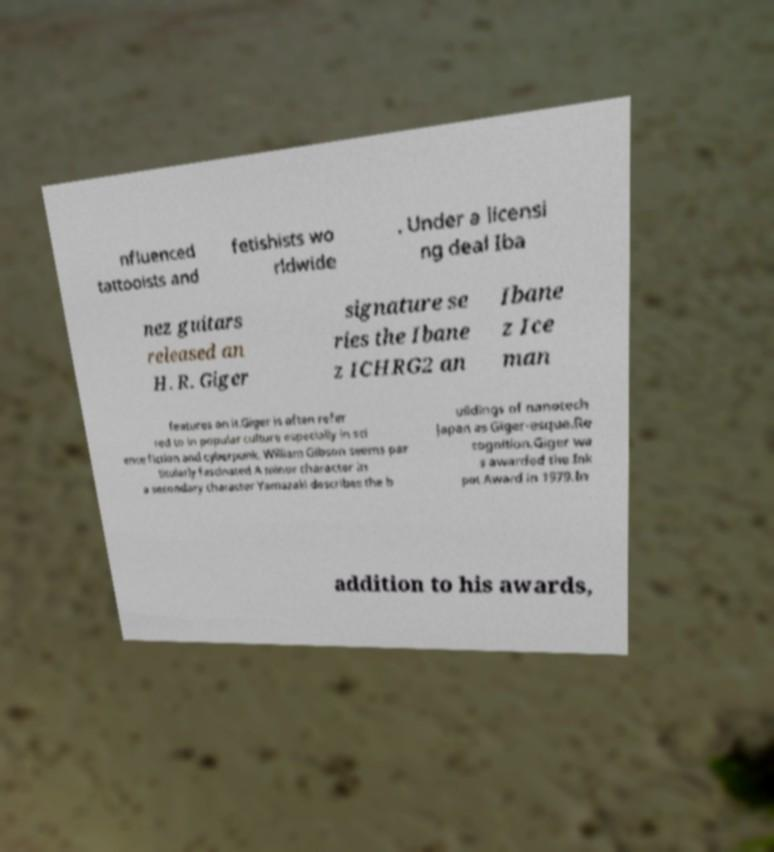Could you extract and type out the text from this image? nfluenced tattooists and fetishists wo rldwide . Under a licensi ng deal Iba nez guitars released an H. R. Giger signature se ries the Ibane z ICHRG2 an Ibane z Ice man features on it.Giger is often refer red to in popular culture especially in sci ence fiction and cyberpunk. William Gibson seems par ticularly fascinated A minor character in a secondary character Yamazaki describes the b uildings of nanotech Japan as Giger-esque.Re cognition.Giger wa s awarded the Ink pot Award in 1979.In addition to his awards, 